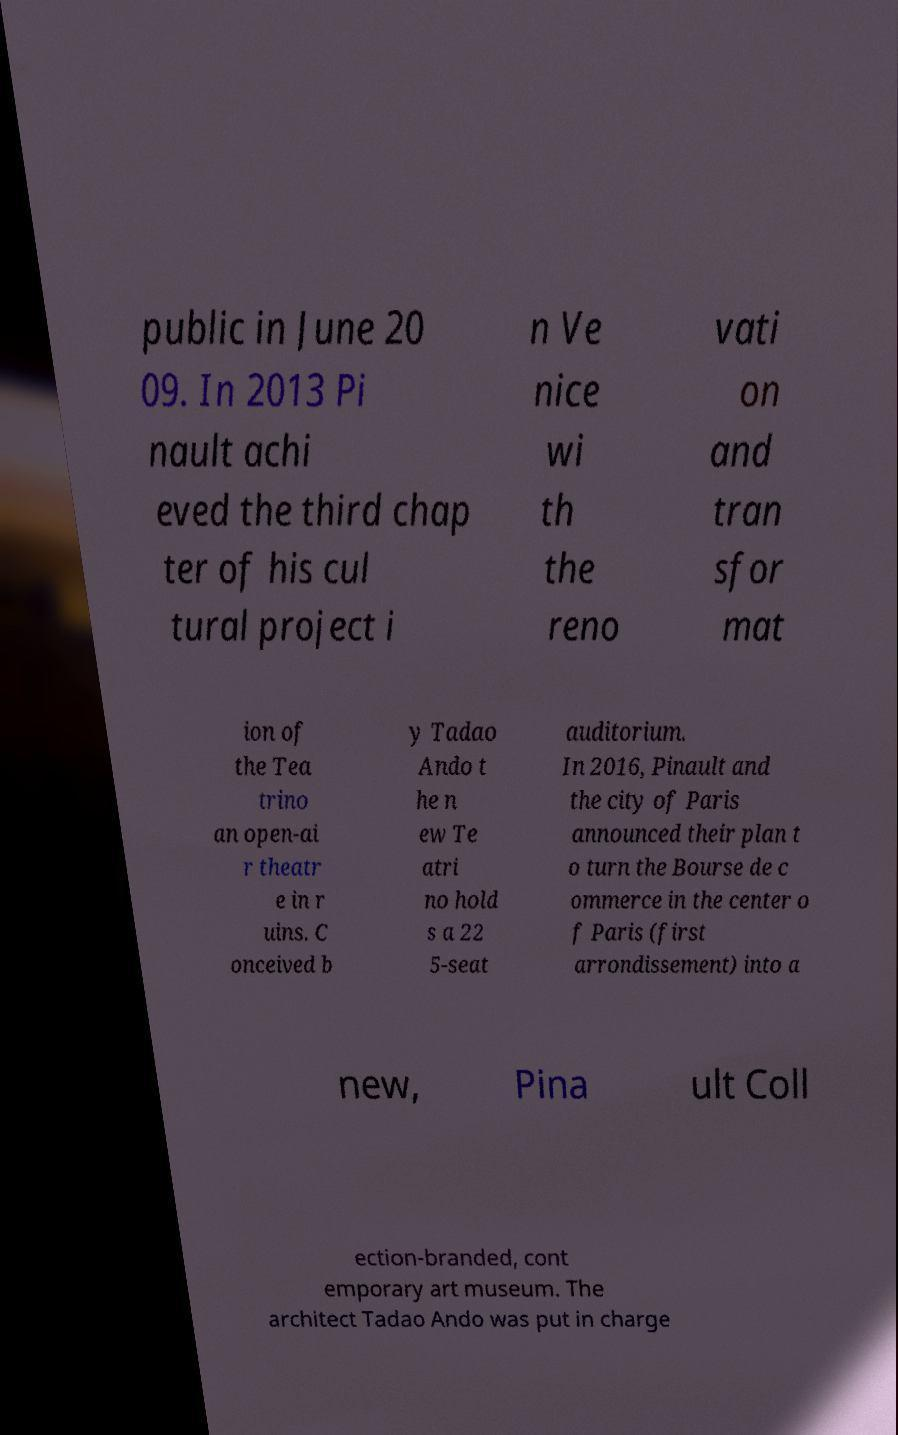Could you extract and type out the text from this image? public in June 20 09. In 2013 Pi nault achi eved the third chap ter of his cul tural project i n Ve nice wi th the reno vati on and tran sfor mat ion of the Tea trino an open-ai r theatr e in r uins. C onceived b y Tadao Ando t he n ew Te atri no hold s a 22 5-seat auditorium. In 2016, Pinault and the city of Paris announced their plan t o turn the Bourse de c ommerce in the center o f Paris (first arrondissement) into a new, Pina ult Coll ection-branded, cont emporary art museum. The architect Tadao Ando was put in charge 